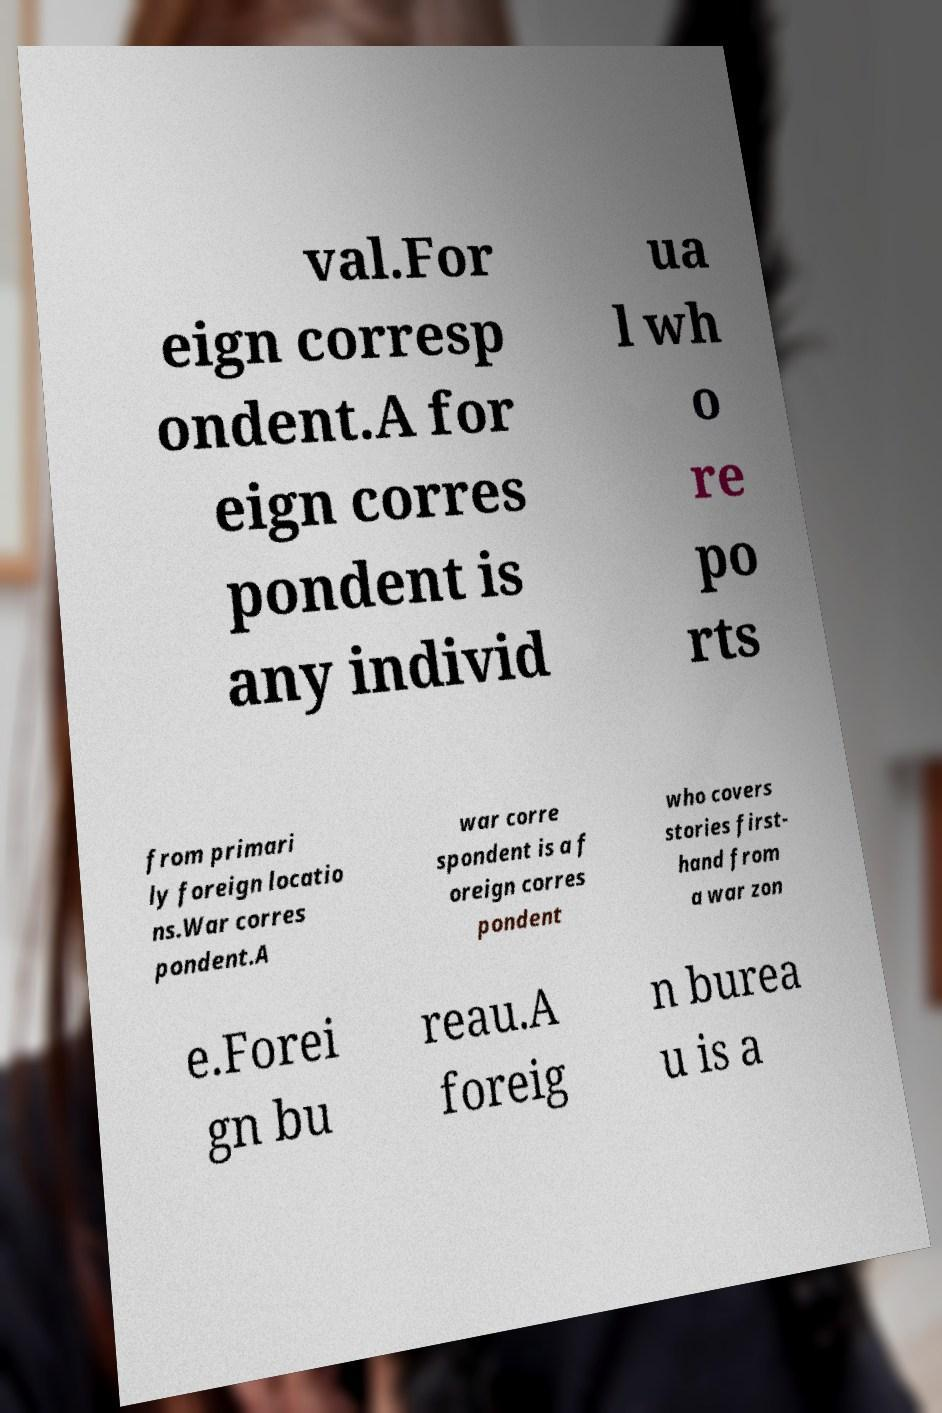For documentation purposes, I need the text within this image transcribed. Could you provide that? val.For eign corresp ondent.A for eign corres pondent is any individ ua l wh o re po rts from primari ly foreign locatio ns.War corres pondent.A war corre spondent is a f oreign corres pondent who covers stories first- hand from a war zon e.Forei gn bu reau.A foreig n burea u is a 